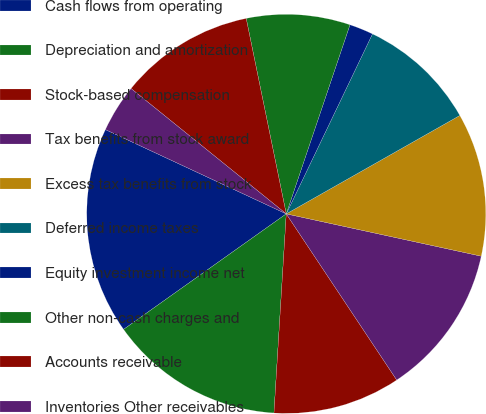Convert chart. <chart><loc_0><loc_0><loc_500><loc_500><pie_chart><fcel>Cash flows from operating<fcel>Depreciation and amortization<fcel>Stock-based compensation<fcel>Tax benefits from stock award<fcel>Excess tax benefits from stock<fcel>Deferred income taxes<fcel>Equity investment income net<fcel>Other non-cash charges and<fcel>Accounts receivable<fcel>Inventories Other receivables<nl><fcel>16.77%<fcel>14.19%<fcel>10.32%<fcel>12.26%<fcel>11.61%<fcel>9.68%<fcel>1.94%<fcel>8.39%<fcel>10.97%<fcel>3.87%<nl></chart> 